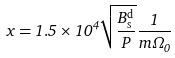Convert formula to latex. <formula><loc_0><loc_0><loc_500><loc_500>x = 1 . 5 \times 1 0 ^ { 4 } \sqrt { \frac { B _ { \mathrm s } ^ { \mathrm d } } { P } } \frac { 1 } { m \Omega _ { 0 } }</formula> 